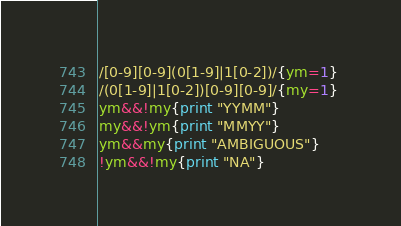Convert code to text. <code><loc_0><loc_0><loc_500><loc_500><_Awk_>/[0-9][0-9](0[1-9]|1[0-2])/{ym=1} 
/(0[1-9]|1[0-2])[0-9][0-9]/{my=1} 
ym&&!my{print "YYMM"} 
my&&!ym{print "MMYY"} 
ym&&my{print "AMBIGUOUS"} 
!ym&&!my{print "NA"}</code> 